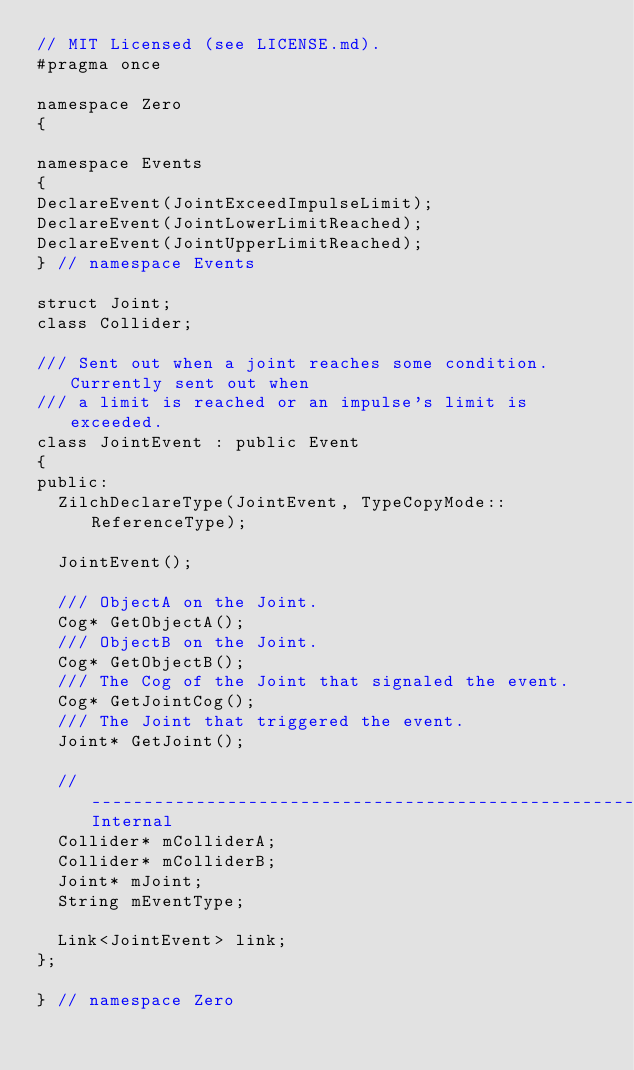Convert code to text. <code><loc_0><loc_0><loc_500><loc_500><_C++_>// MIT Licensed (see LICENSE.md).
#pragma once

namespace Zero
{

namespace Events
{
DeclareEvent(JointExceedImpulseLimit);
DeclareEvent(JointLowerLimitReached);
DeclareEvent(JointUpperLimitReached);
} // namespace Events

struct Joint;
class Collider;

/// Sent out when a joint reaches some condition. Currently sent out when
/// a limit is reached or an impulse's limit is exceeded.
class JointEvent : public Event
{
public:
  ZilchDeclareType(JointEvent, TypeCopyMode::ReferenceType);

  JointEvent();

  /// ObjectA on the Joint.
  Cog* GetObjectA();
  /// ObjectB on the Joint.
  Cog* GetObjectB();
  /// The Cog of the Joint that signaled the event.
  Cog* GetJointCog();
  /// The Joint that triggered the event.
  Joint* GetJoint();

  //-------------------------------------------------------------------Internal
  Collider* mColliderA;
  Collider* mColliderB;
  Joint* mJoint;
  String mEventType;

  Link<JointEvent> link;
};

} // namespace Zero
</code> 